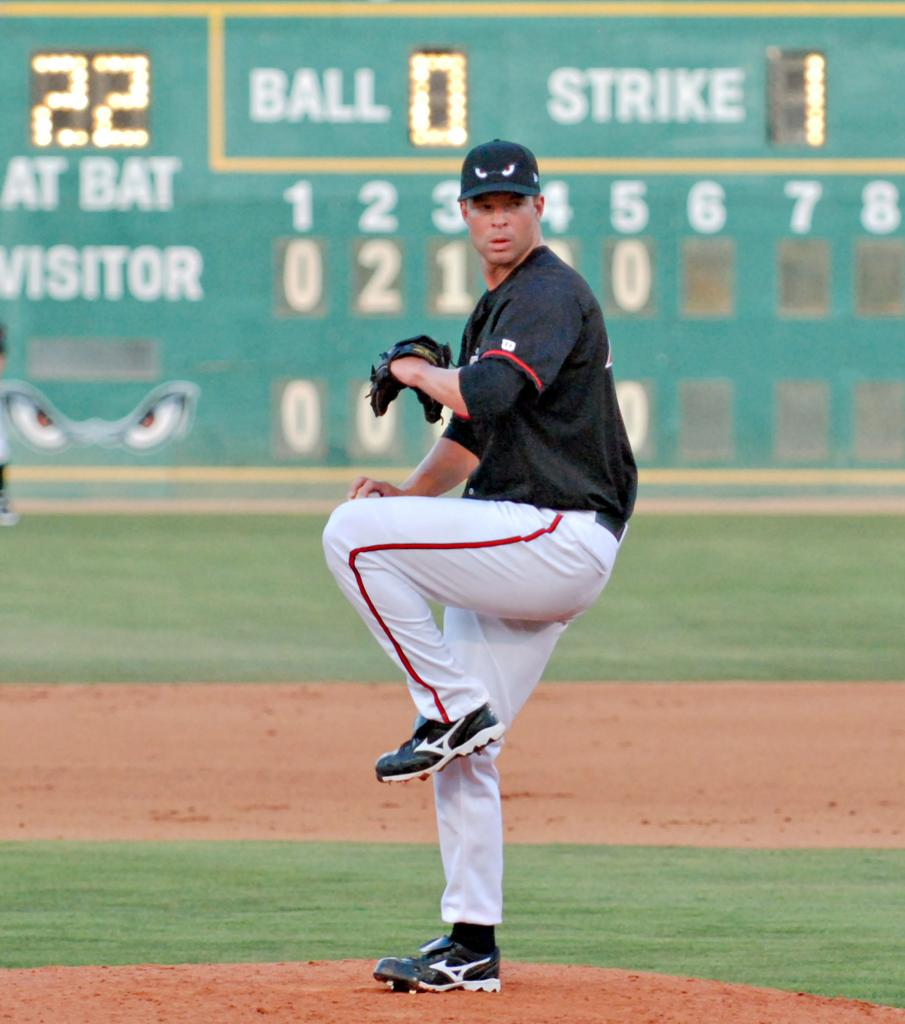<image>
Create a compact narrative representing the image presented. a player with the number 22 on a scoreboard 